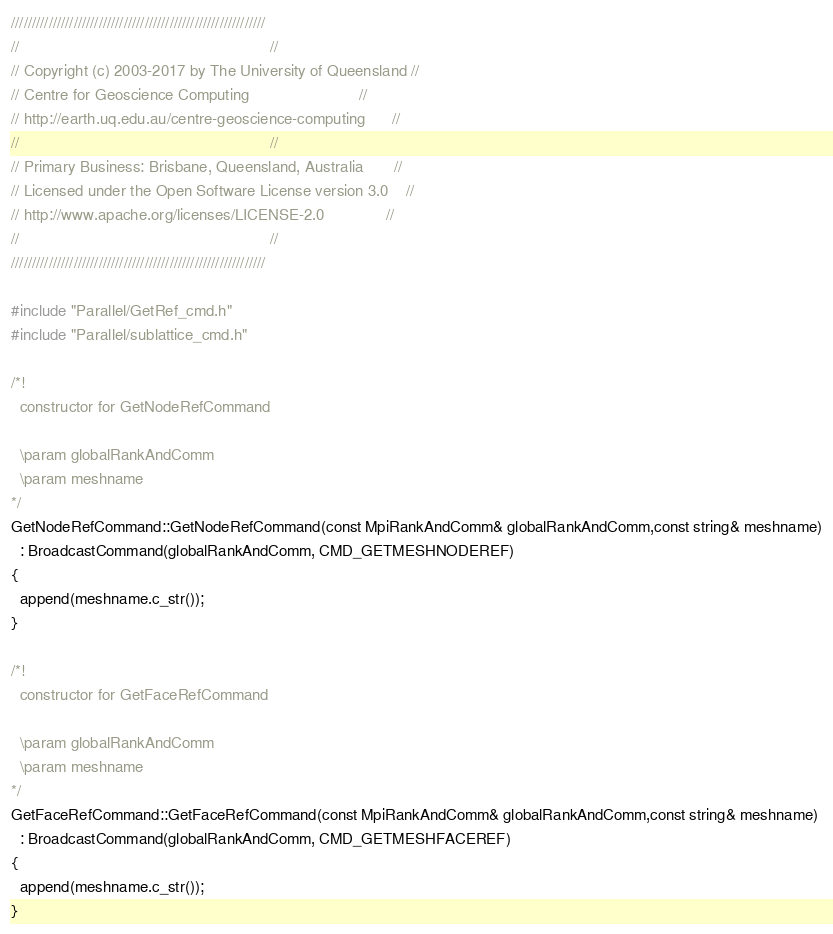Convert code to text. <code><loc_0><loc_0><loc_500><loc_500><_C++_>/////////////////////////////////////////////////////////////
//                                                         //
// Copyright (c) 2003-2017 by The University of Queensland //
// Centre for Geoscience Computing                         //
// http://earth.uq.edu.au/centre-geoscience-computing      //
//                                                         //
// Primary Business: Brisbane, Queensland, Australia       //
// Licensed under the Open Software License version 3.0    //
// http://www.apache.org/licenses/LICENSE-2.0              //
//                                                         //
/////////////////////////////////////////////////////////////

#include "Parallel/GetRef_cmd.h"
#include "Parallel/sublattice_cmd.h"

/*!
  constructor for GetNodeRefCommand

  \param globalRankAndComm
  \param meshname
*/
GetNodeRefCommand::GetNodeRefCommand(const MpiRankAndComm& globalRankAndComm,const string& meshname)
  : BroadcastCommand(globalRankAndComm, CMD_GETMESHNODEREF)
{
  append(meshname.c_str());
}

/*!
  constructor for GetFaceRefCommand

  \param globalRankAndComm
  \param meshname
*/
GetFaceRefCommand::GetFaceRefCommand(const MpiRankAndComm& globalRankAndComm,const string& meshname)
  : BroadcastCommand(globalRankAndComm, CMD_GETMESHFACEREF)
{
  append(meshname.c_str());
}
</code> 